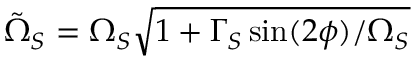<formula> <loc_0><loc_0><loc_500><loc_500>\tilde { \Omega } _ { S } = \Omega _ { S } \sqrt { 1 + \Gamma _ { S } \sin ( 2 \phi ) / \Omega _ { S } }</formula> 